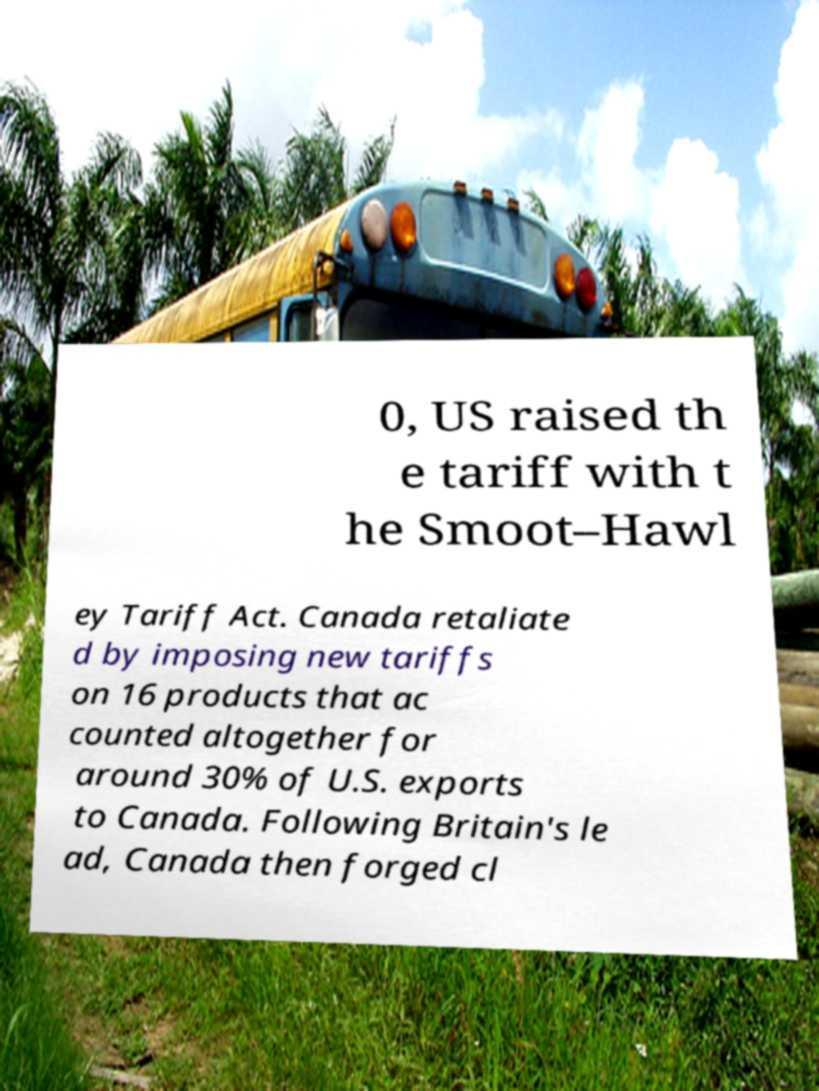Can you read and provide the text displayed in the image?This photo seems to have some interesting text. Can you extract and type it out for me? 0, US raised th e tariff with t he Smoot–Hawl ey Tariff Act. Canada retaliate d by imposing new tariffs on 16 products that ac counted altogether for around 30% of U.S. exports to Canada. Following Britain's le ad, Canada then forged cl 